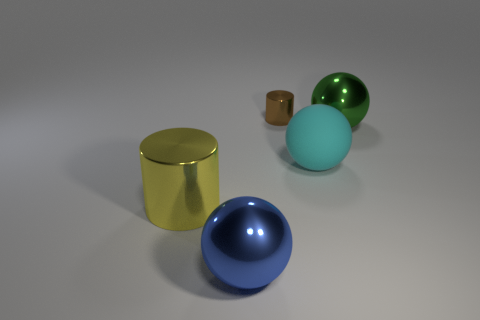What color is the rubber thing? cyan 